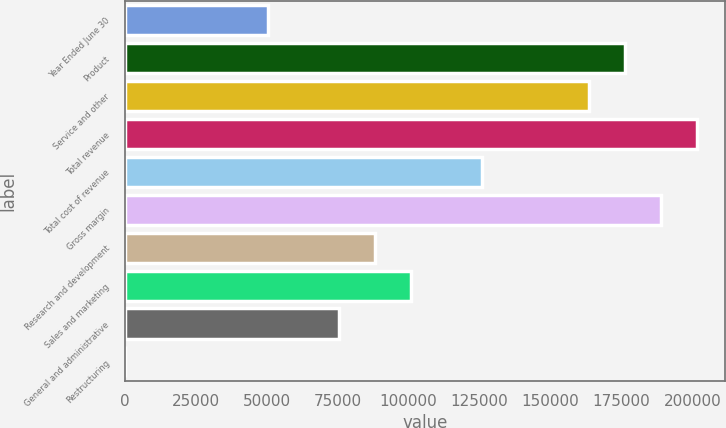Convert chart to OTSL. <chart><loc_0><loc_0><loc_500><loc_500><bar_chart><fcel>Year Ended June 30<fcel>Product<fcel>Service and other<fcel>Total revenue<fcel>Total cost of revenue<fcel>Gross margin<fcel>Research and development<fcel>Sales and marketing<fcel>General and administrative<fcel>Restructuring<nl><fcel>50339.5<fcel>176179<fcel>163595<fcel>201347<fcel>125843<fcel>188763<fcel>88091.2<fcel>100675<fcel>75507.3<fcel>3.75<nl></chart> 